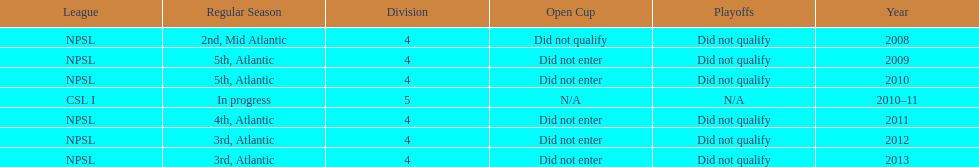What is the lowest place they came in 5th. 